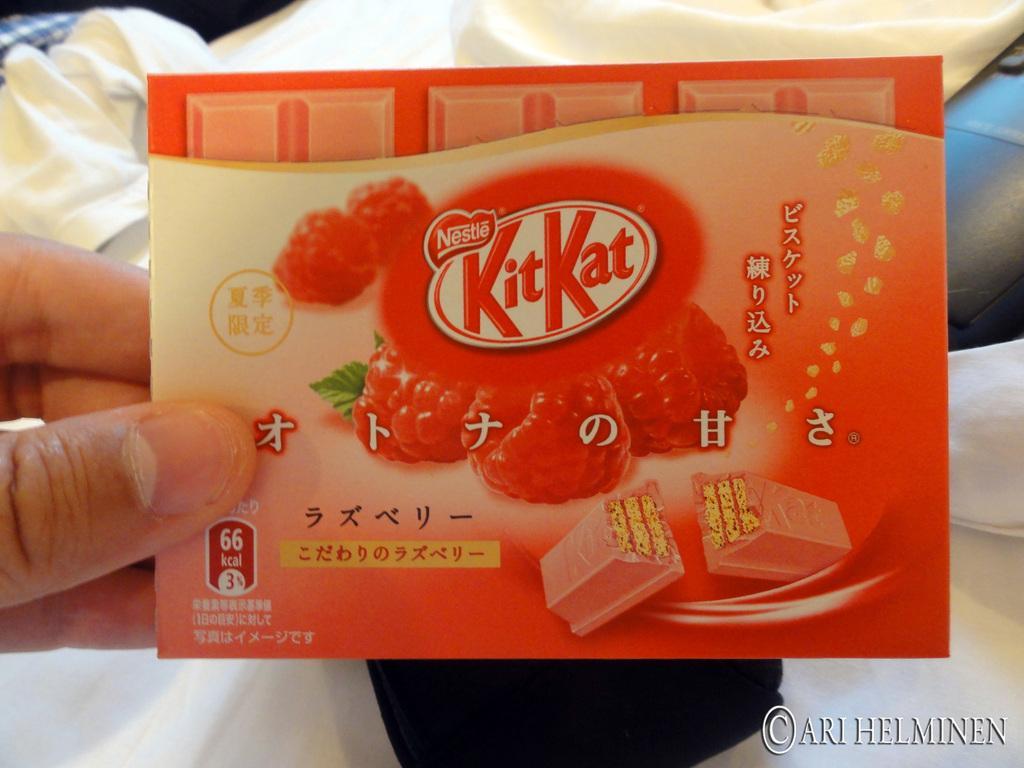Could you give a brief overview of what you see in this image? In this image we can see a person holding chocolate wrapper in the hands. In the background there are clothes. 